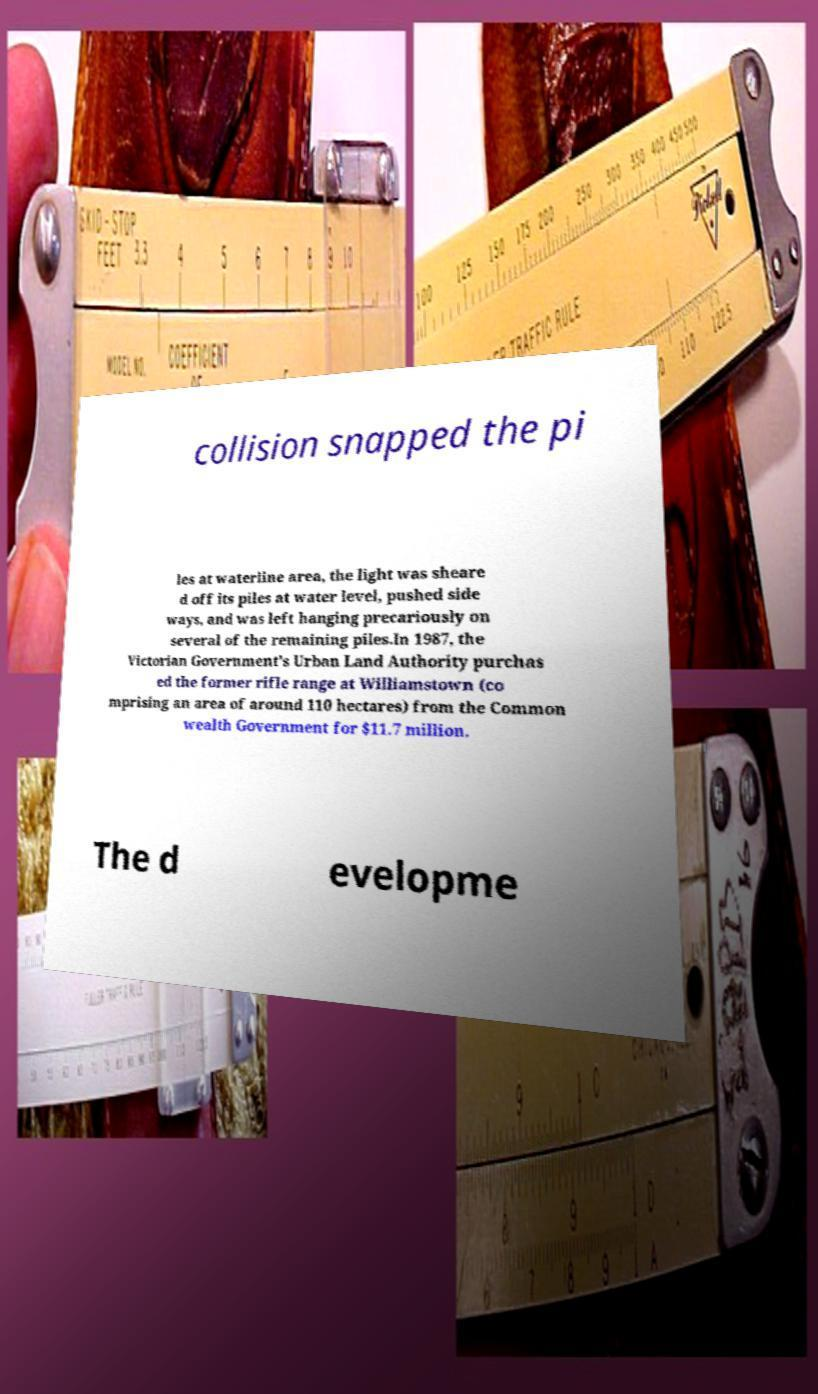For documentation purposes, I need the text within this image transcribed. Could you provide that? collision snapped the pi les at waterline area, the light was sheare d off its piles at water level, pushed side ways, and was left hanging precariously on several of the remaining piles.In 1987, the Victorian Government's Urban Land Authority purchas ed the former rifle range at Williamstown (co mprising an area of around 110 hectares) from the Common wealth Government for $11.7 million. The d evelopme 